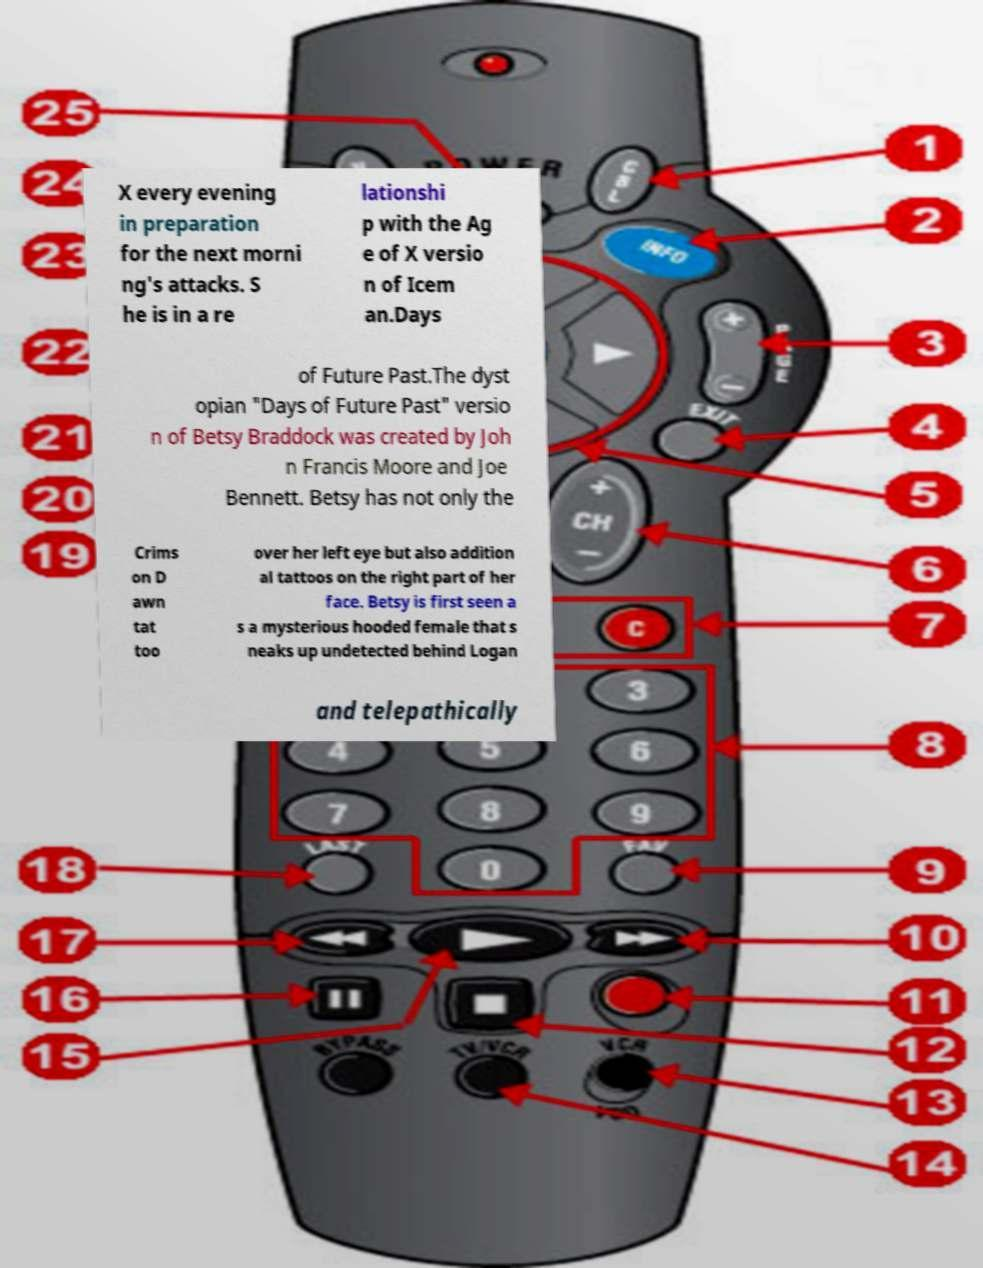Please identify and transcribe the text found in this image. X every evening in preparation for the next morni ng's attacks. S he is in a re lationshi p with the Ag e of X versio n of Icem an.Days of Future Past.The dyst opian "Days of Future Past" versio n of Betsy Braddock was created by Joh n Francis Moore and Joe Bennett. Betsy has not only the Crims on D awn tat too over her left eye but also addition al tattoos on the right part of her face. Betsy is first seen a s a mysterious hooded female that s neaks up undetected behind Logan and telepathically 